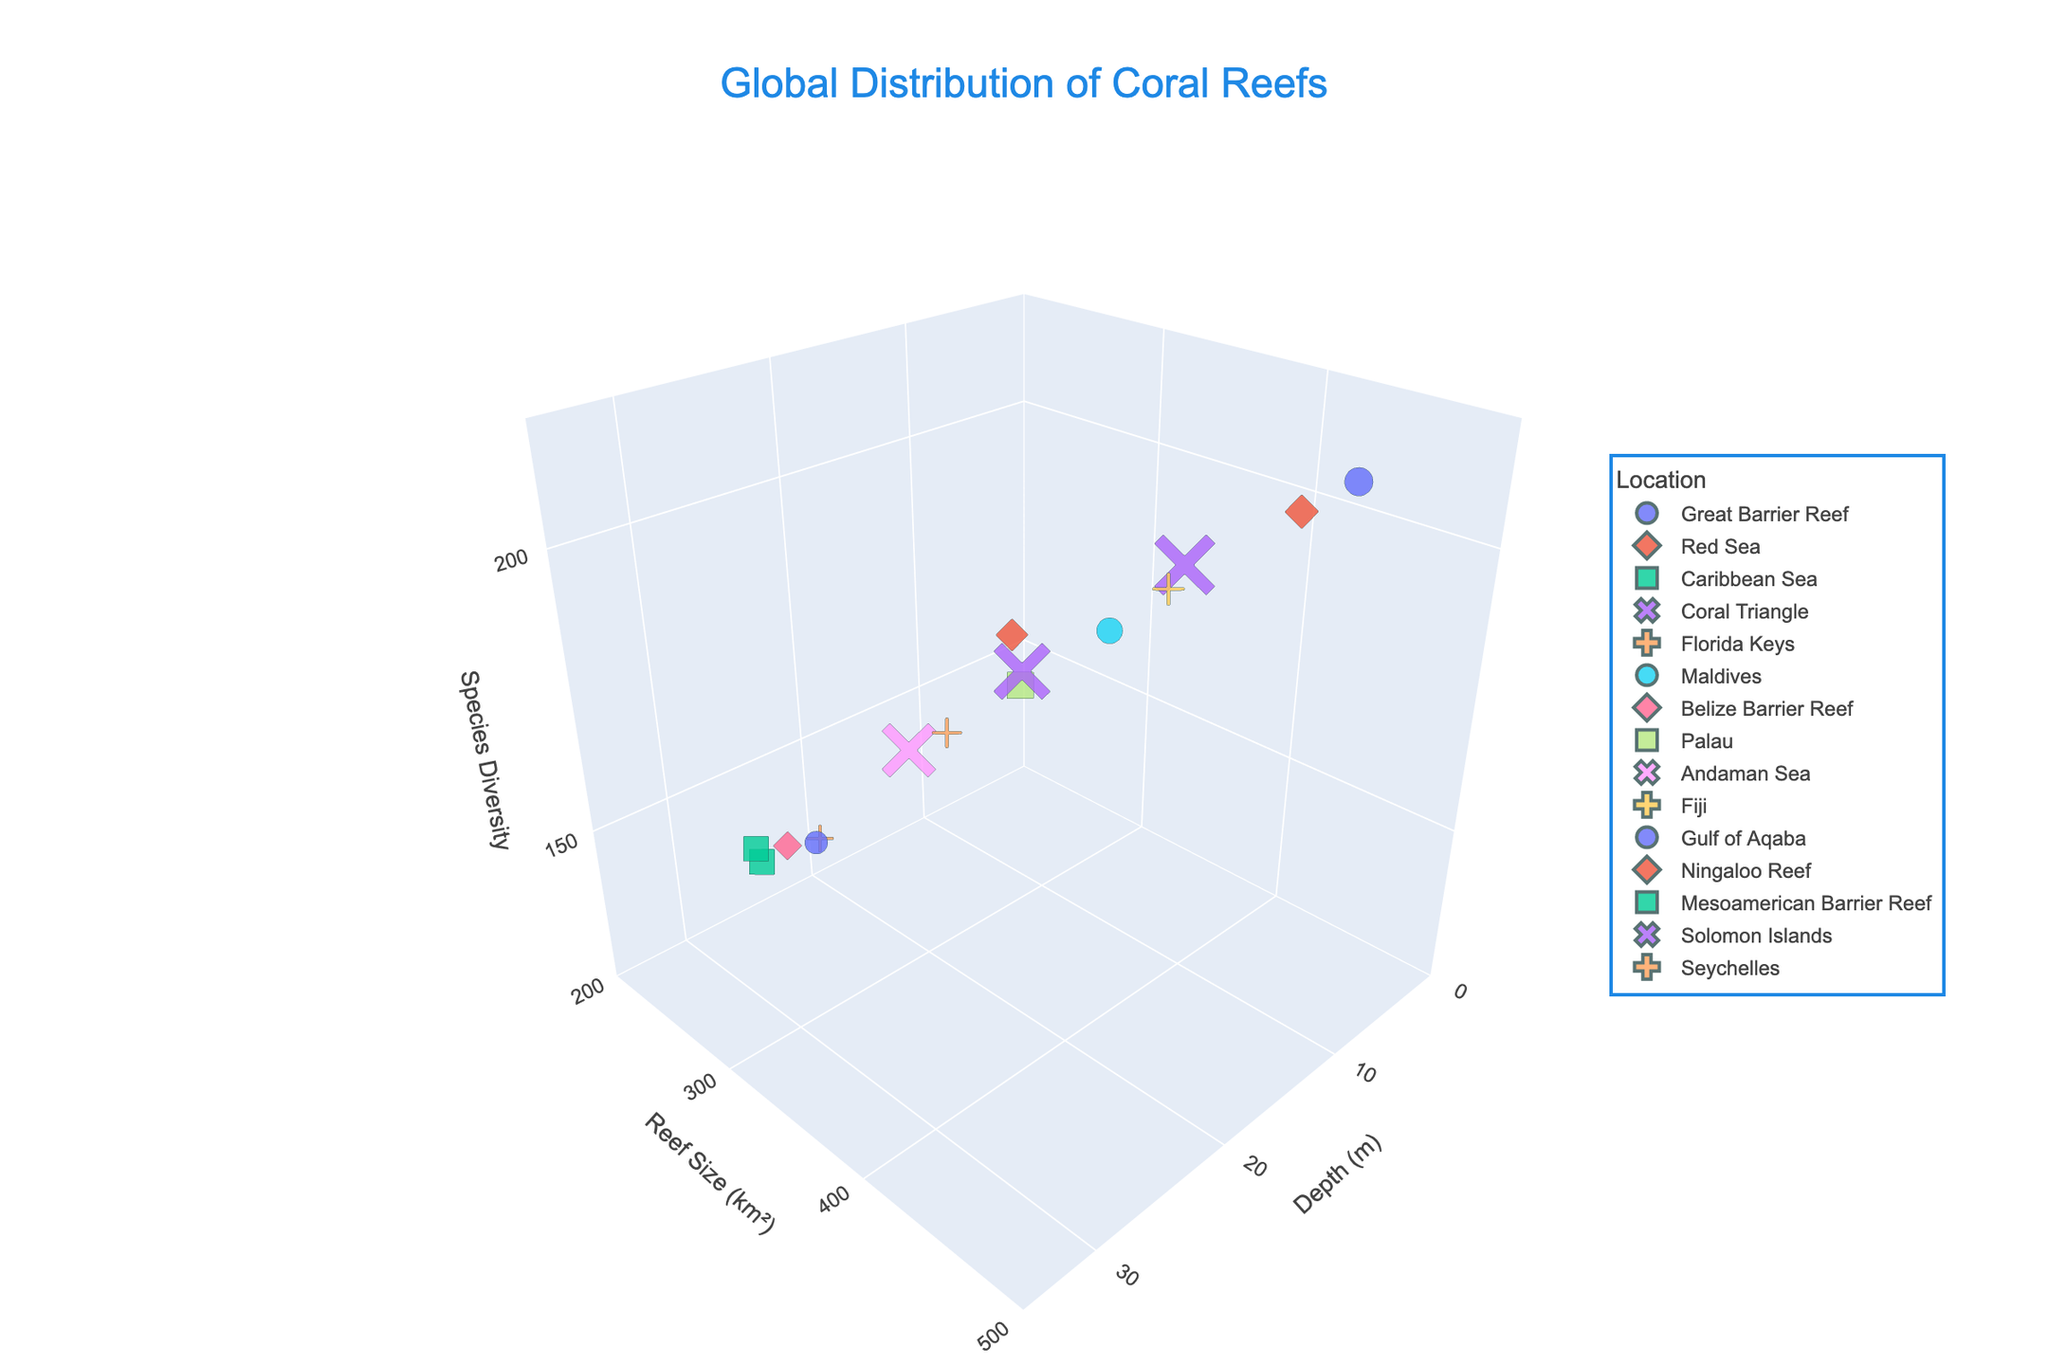What is the title of the plot? The title is located at the top of the chart and is easily visible in a larger font above the plot area.
Answer: Global Distribution of Coral Reefs What are the units for the 'Size' axis in the plot? The 'Size' axis label, found on the y-axis, indicates the units used.
Answer: km² How many data points are represented in the plot? By counting the individual markers, each representing a location's data on coral reefs, we can determine the number of data points.
Answer: 15 Which reef has the greatest depth, and what is its depth? Identify the marker that is positioned furthest right on the depth (m) axis, and check the hover text or color legend for the reef name and depth value.
Answer: Mesoamerican Barrier Reef, 28 m Which reef has the highest species diversity? Locate the marker with the highest position on the vertical (z) axis, representing species diversity, and check the hover text for the reef name and species diversity value.
Answer: Great Barrier Reef, 210 What is the average reef size for all the reefs shown? Sum the 'Size (km²)' values for all reefs and divide by the number of data points. (450 + 320 + 280 + 390 + 210 + 330 + 240 + 300 + 270 + 360 + 230 + 410 + 250 + 310 + 290) / 15 = 4440 / 15 = 296.
Answer: 296 km² Are there more reefs with a depth less than 10 meters or greater than 20 meters? Count the number of markers with a depth less than 10 and those with a depth greater than 20. Less than 10 meters: 4 (Great Barrier Reef, Ningaloo Reef, Fiji, Maldives). Greater than 20 meters: 4 (Mesoamerican Barrier Reef, Belize Barrier Reef, Gulf of Aqaba, Florida Keys).
Answer: Equal number Which two reefs are most similar in their size and species diversity? Find the markers that are closest together in both the y-axis (size) and z-axis (species diversity) dimensions.
Answer: Solomon Islands and Seychelles What is the median depth of the reefs? Arrange the 'Depth (m)' values in numeric order and find the middle value (or the average of the two middle values if the number of points is even). Depths: 3, 5, 7, 8, 10, 12, 13, 15, 17, 18, 20, 22, 25, 28, 30. Median value: 15.
Answer: 15 m Which reef occupies the largest area, and what is its area? Identify the marker highest on the y-axis (Reef Size in km²) and check the hover text for the reef name and size value.
Answer: Great Barrier Reef, 450 km² 